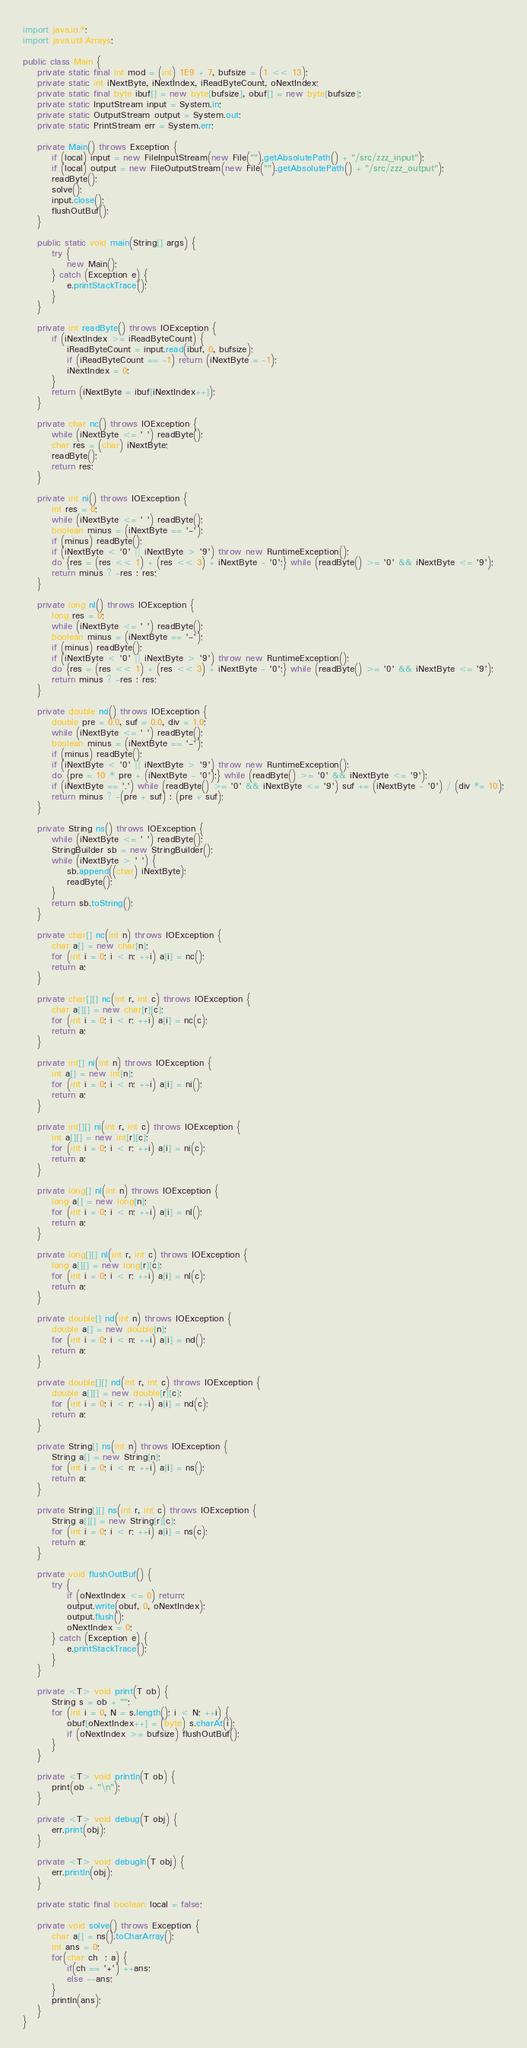<code> <loc_0><loc_0><loc_500><loc_500><_Java_>import java.io.*;
import java.util.Arrays;

public class Main {
	private static final int mod = (int) 1E9 + 7, bufsize = (1 << 13);
	private static int iNextByte, iNextIndex, iReadByteCount, oNextIndex;
	private static final byte ibuf[] = new byte[bufsize], obuf[] = new byte[bufsize];
	private static InputStream input = System.in;
	private static OutputStream output = System.out;
	private static PrintStream err = System.err;

	private Main() throws Exception {
		if (local) input = new FileInputStream(new File("").getAbsolutePath() + "/src/zzz_input");
		if (local) output = new FileOutputStream(new File("").getAbsolutePath() + "/src/zzz_output");
		readByte();
		solve();
		input.close();
		flushOutBuf();
	}

	public static void main(String[] args) {
		try {
			new Main();
		} catch (Exception e) {
			e.printStackTrace();
		}
	}

	private int readByte() throws IOException {
		if (iNextIndex >= iReadByteCount) {
			iReadByteCount = input.read(ibuf, 0, bufsize);
			if (iReadByteCount == -1) return (iNextByte = -1);
			iNextIndex = 0;
		}
		return (iNextByte = ibuf[iNextIndex++]);
	}

	private char nc() throws IOException {
		while (iNextByte <= ' ') readByte();
		char res = (char) iNextByte;
		readByte();
		return res;
	}

	private int ni() throws IOException {
		int res = 0;
		while (iNextByte <= ' ') readByte();
		boolean minus = (iNextByte == '-');
		if (minus) readByte();
		if (iNextByte < '0' || iNextByte > '9') throw new RuntimeException();
		do {res = (res << 1) + (res << 3) + iNextByte - '0';} while (readByte() >= '0' && iNextByte <= '9');
		return minus ? -res : res;
	}

	private long nl() throws IOException {
		long res = 0;
		while (iNextByte <= ' ') readByte();
		boolean minus = (iNextByte == '-');
		if (minus) readByte();
		if (iNextByte < '0' || iNextByte > '9') throw new RuntimeException();
		do {res = (res << 1) + (res << 3) + iNextByte - '0';} while (readByte() >= '0' && iNextByte <= '9');
		return minus ? -res : res;
	}

	private double nd() throws IOException {
		double pre = 0.0, suf = 0.0, div = 1.0;
		while (iNextByte <= ' ') readByte();
		boolean minus = (iNextByte == '-');
		if (minus) readByte();
		if (iNextByte < '0' || iNextByte > '9') throw new RuntimeException();
		do {pre = 10 * pre + (iNextByte - '0');} while (readByte() >= '0' && iNextByte <= '9');
		if (iNextByte == '.') while (readByte() >= '0' && iNextByte <= '9') suf += (iNextByte - '0') / (div *= 10);
		return minus ? -(pre + suf) : (pre + suf);
	}

	private String ns() throws IOException {
		while (iNextByte <= ' ') readByte();
		StringBuilder sb = new StringBuilder();
		while (iNextByte > ' ') {
			sb.append((char) iNextByte);
			readByte();
		}
		return sb.toString();
	}

	private char[] nc(int n) throws IOException {
		char a[] = new char[n];
		for (int i = 0; i < n; ++i) a[i] = nc();
		return a;
	}

	private char[][] nc(int r, int c) throws IOException {
		char a[][] = new char[r][c];
		for (int i = 0; i < r; ++i) a[i] = nc(c);
		return a;
	}

	private int[] ni(int n) throws IOException {
		int a[] = new int[n];
		for (int i = 0; i < n; ++i) a[i] = ni();
		return a;
	}

	private int[][] ni(int r, int c) throws IOException {
		int a[][] = new int[r][c];
		for (int i = 0; i < r; ++i) a[i] = ni(c);
		return a;
	}

	private long[] nl(int n) throws IOException {
		long a[] = new long[n];
		for (int i = 0; i < n; ++i) a[i] = nl();
		return a;
	}

	private long[][] nl(int r, int c) throws IOException {
		long a[][] = new long[r][c];
		for (int i = 0; i < r; ++i) a[i] = nl(c);
		return a;
	}

	private double[] nd(int n) throws IOException {
		double a[] = new double[n];
		for (int i = 0; i < n; ++i) a[i] = nd();
		return a;
	}

	private double[][] nd(int r, int c) throws IOException {
		double a[][] = new double[r][c];
		for (int i = 0; i < r; ++i) a[i] = nd(c);
		return a;
	}

	private String[] ns(int n) throws IOException {
		String a[] = new String[n];
		for (int i = 0; i < n; ++i) a[i] = ns();
		return a;
	}

	private String[][] ns(int r, int c) throws IOException {
		String a[][] = new String[r][c];
		for (int i = 0; i < r; ++i) a[i] = ns(c);
		return a;
	}

	private void flushOutBuf() {
		try {
			if (oNextIndex <= 0) return;
			output.write(obuf, 0, oNextIndex);
			output.flush();
			oNextIndex = 0;
		} catch (Exception e) {
			e.printStackTrace();
		}
	}

	private <T> void print(T ob) {
		String s = ob + "";
		for (int i = 0, N = s.length(); i < N; ++i) {
			obuf[oNextIndex++] = (byte) s.charAt(i);
			if (oNextIndex >= bufsize) flushOutBuf();
		}
	}

	private <T> void println(T ob) {
		print(ob + "\n");
	}

	private <T> void debug(T obj) {
		err.print(obj);
	}

	private <T> void debugln(T obj) {
		err.println(obj);
	}

	private static final boolean local = false;

	private void solve() throws Exception {
		char a[] = ns().toCharArray();
		int ans = 0;
		for(char ch  : a) {
			if(ch == '+') ++ans;
			else --ans;
		}
		println(ans);
	}
}
</code> 